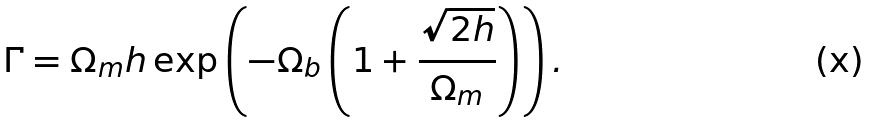<formula> <loc_0><loc_0><loc_500><loc_500>\Gamma = \Omega _ { m } h \exp \left ( - \Omega _ { b } \left ( 1 + \frac { \sqrt { 2 h } } { \Omega _ { m } } \right ) \right ) .</formula> 